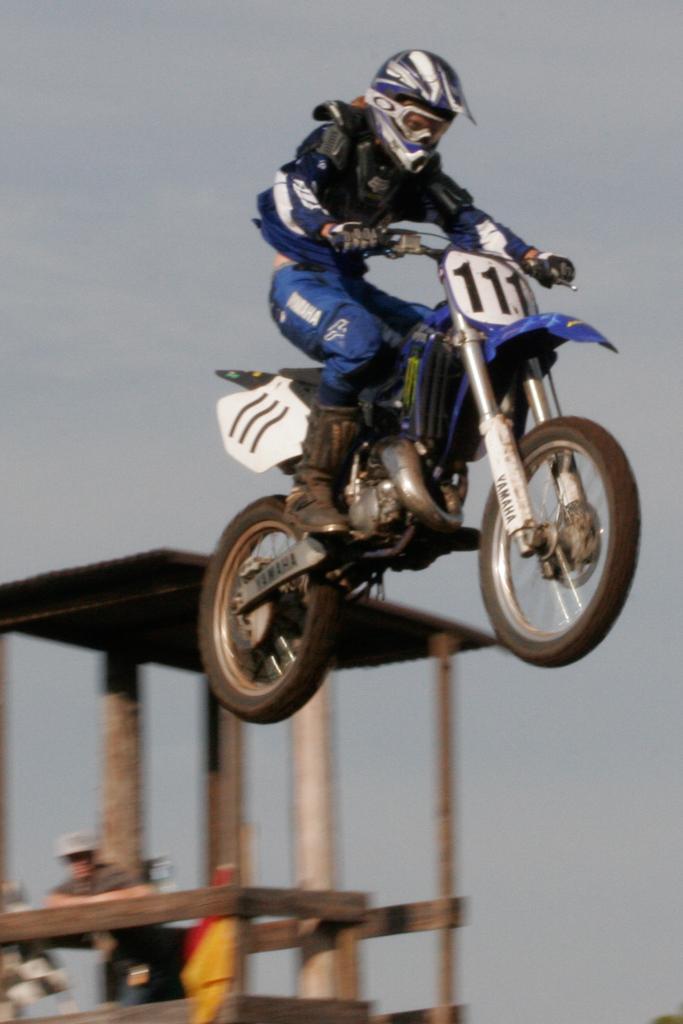Describe this image in one or two sentences. In this image I see a person who is on the bike and I see 3 numbers written over here and I see the rods over here and I see a person over here. In the background I see the sky and I can also see that this person is wearing a helmet which is of white and blue in color. 